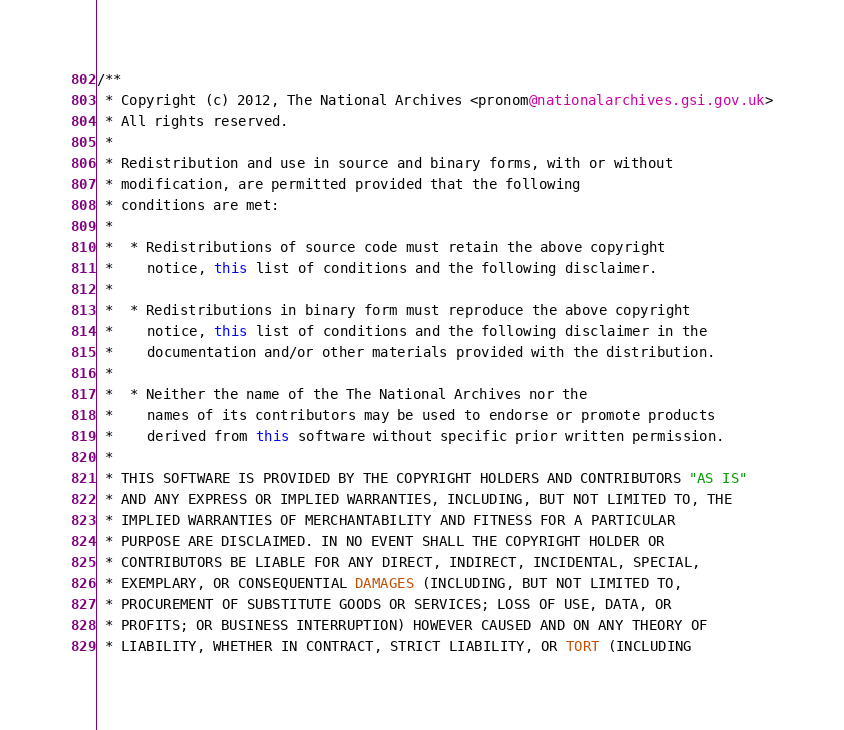<code> <loc_0><loc_0><loc_500><loc_500><_Java_>/**
 * Copyright (c) 2012, The National Archives <pronom@nationalarchives.gsi.gov.uk>
 * All rights reserved.
 *
 * Redistribution and use in source and binary forms, with or without
 * modification, are permitted provided that the following
 * conditions are met:
 *
 *  * Redistributions of source code must retain the above copyright
 *    notice, this list of conditions and the following disclaimer.
 *
 *  * Redistributions in binary form must reproduce the above copyright
 *    notice, this list of conditions and the following disclaimer in the
 *    documentation and/or other materials provided with the distribution.
 *
 *  * Neither the name of the The National Archives nor the
 *    names of its contributors may be used to endorse or promote products
 *    derived from this software without specific prior written permission.
 *
 * THIS SOFTWARE IS PROVIDED BY THE COPYRIGHT HOLDERS AND CONTRIBUTORS "AS IS"
 * AND ANY EXPRESS OR IMPLIED WARRANTIES, INCLUDING, BUT NOT LIMITED TO, THE
 * IMPLIED WARRANTIES OF MERCHANTABILITY AND FITNESS FOR A PARTICULAR
 * PURPOSE ARE DISCLAIMED. IN NO EVENT SHALL THE COPYRIGHT HOLDER OR
 * CONTRIBUTORS BE LIABLE FOR ANY DIRECT, INDIRECT, INCIDENTAL, SPECIAL,
 * EXEMPLARY, OR CONSEQUENTIAL DAMAGES (INCLUDING, BUT NOT LIMITED TO,
 * PROCUREMENT OF SUBSTITUTE GOODS OR SERVICES; LOSS OF USE, DATA, OR
 * PROFITS; OR BUSINESS INTERRUPTION) HOWEVER CAUSED AND ON ANY THEORY OF
 * LIABILITY, WHETHER IN CONTRACT, STRICT LIABILITY, OR TORT (INCLUDING</code> 